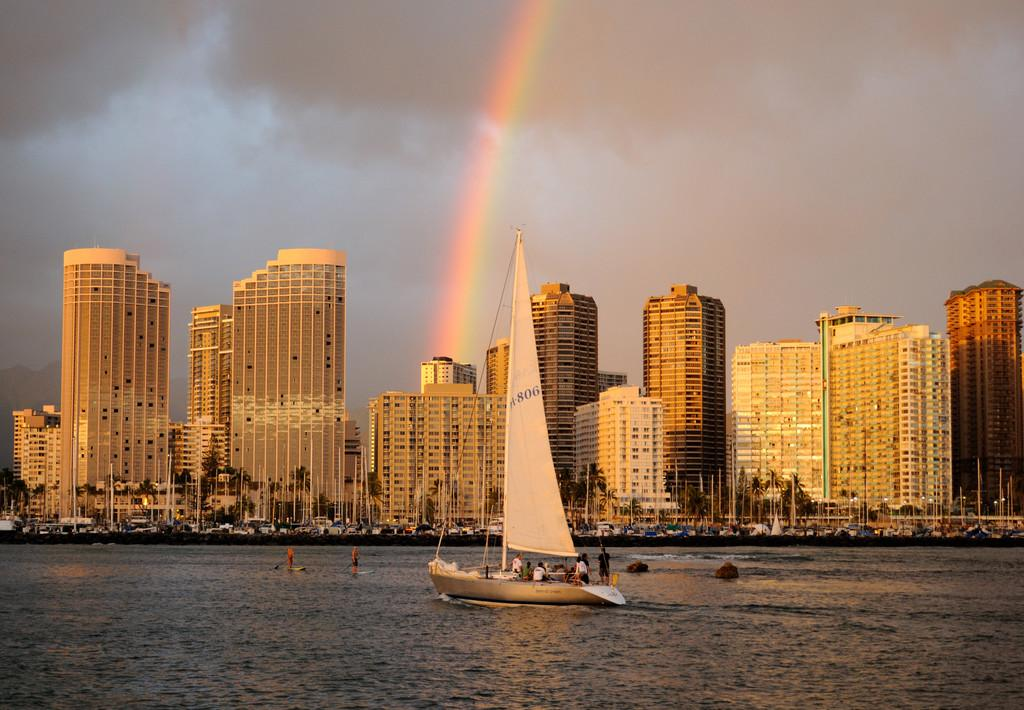What is the main subject of the image? The main subject of the image is a ship sailing on a water surface. What can be seen in the background of the image? In the background of the image, there are tall buildings, trees, poles, and other unspecified objects. What type of environment is depicted in the image? The image depicts a water surface with a ship and a background that includes both natural and man-made elements. Where is the zoo located in the image? There is no zoo present in the image. What type of bread is being used to mark the boundary in the image? There is no bread or boundary present in the image. 